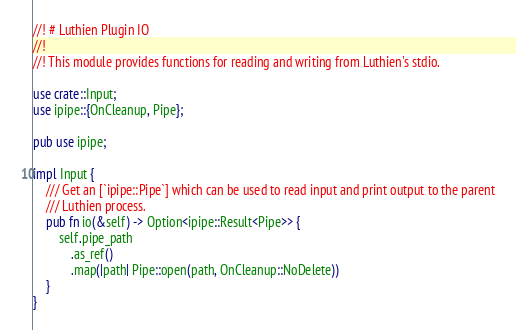Convert code to text. <code><loc_0><loc_0><loc_500><loc_500><_Rust_>//! # Luthien Plugin IO
//!
//! This module provides functions for reading and writing from Luthien's stdio.

use crate::Input;
use ipipe::{OnCleanup, Pipe};

pub use ipipe;

impl Input {
    /// Get an [`ipipe::Pipe`] which can be used to read input and print output to the parent
    /// Luthien process.
    pub fn io(&self) -> Option<ipipe::Result<Pipe>> {
        self.pipe_path
            .as_ref()
            .map(|path| Pipe::open(path, OnCleanup::NoDelete))
    }
}
</code> 